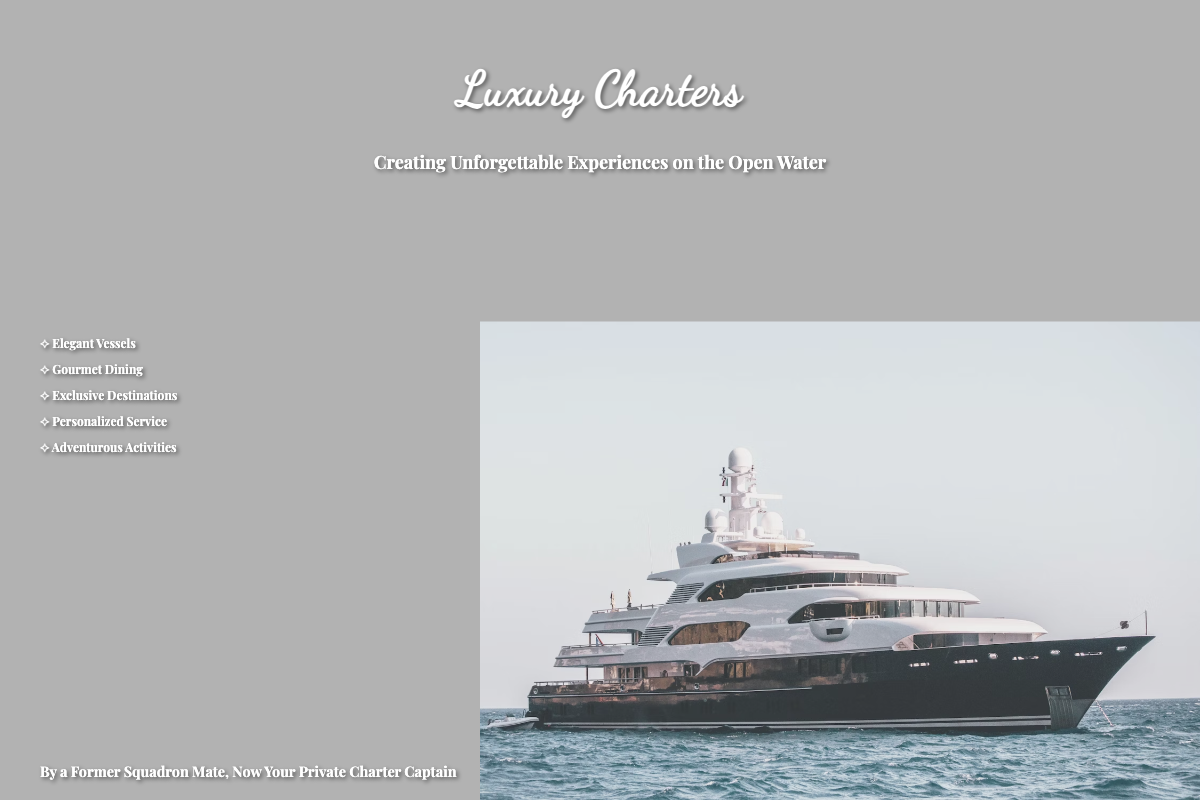What is the title of the book? The title is prominently displayed at the top of the cover.
Answer: Luxury Charters What does the subtitle say? The subtitle appears directly under the title and provides additional context.
Answer: Creating Unforgettable Experiences on the Open Water Who is the author? The author's name is located at the bottom left of the cover.
Answer: By a Former Squadron Mate, Now Your Private Charter Captain Which type of service is highlighted as part of the luxury experience? The cover lists various highlights to capture the essence of the charter experience.
Answer: Personalized Service What type of dining is featured in the highlights? The highlights near the center of the cover indicate the quality of food experience.
Answer: Gourmet Dining What is the aesthetic of the typography used for the title? The typography style is meant to evoke a sense of luxury and elegance.
Answer: Cursive What percentage of the cover shows the yacht image? The yacht image occupies a significant portion of the cover.
Answer: 60% What natural backdrop is depicted in the cover design? The backdrop of the cover features a natural phenomenon that enhances the luxury feel.
Answer: Sunset How many highlights are presented on the cover? The highlights are listed in a specific format that can be counted.
Answer: Five 